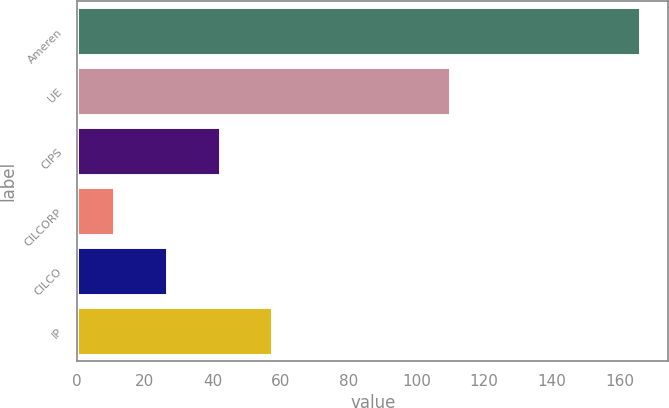<chart> <loc_0><loc_0><loc_500><loc_500><bar_chart><fcel>Ameren<fcel>UE<fcel>CIPS<fcel>CILCORP<fcel>CILCO<fcel>IP<nl><fcel>166<fcel>110<fcel>42<fcel>11<fcel>26.5<fcel>57.5<nl></chart> 